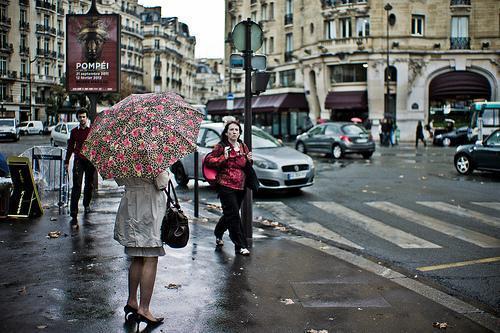How many women have an umbrella?
Give a very brief answer. 1. 